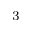Convert formula to latex. <formula><loc_0><loc_0><loc_500><loc_500>^ { 3 }</formula> 